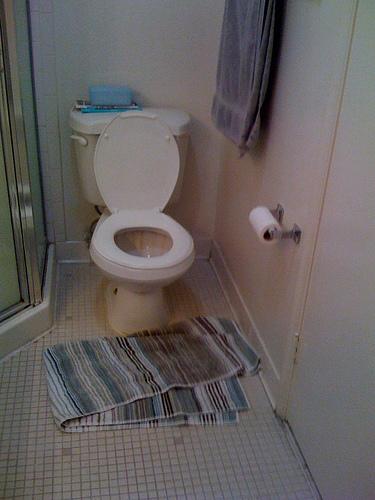What color is the towel on the right?
Give a very brief answer. Gray. What is the floor made of?
Keep it brief. Tile. Is there any toilet paper left on the roll?
Short answer required. Yes. 